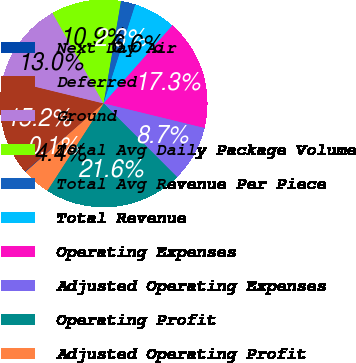Convert chart. <chart><loc_0><loc_0><loc_500><loc_500><pie_chart><fcel>Next Day Air<fcel>Deferred<fcel>Ground<fcel>Total Avg Daily Package Volume<fcel>Total Avg Revenue Per Piece<fcel>Total Revenue<fcel>Operating Expenses<fcel>Adjusted Operating Expenses<fcel>Operating Profit<fcel>Adjusted Operating Profit<nl><fcel>0.11%<fcel>15.16%<fcel>13.01%<fcel>10.86%<fcel>2.26%<fcel>6.56%<fcel>17.31%<fcel>8.71%<fcel>21.61%<fcel>4.41%<nl></chart> 